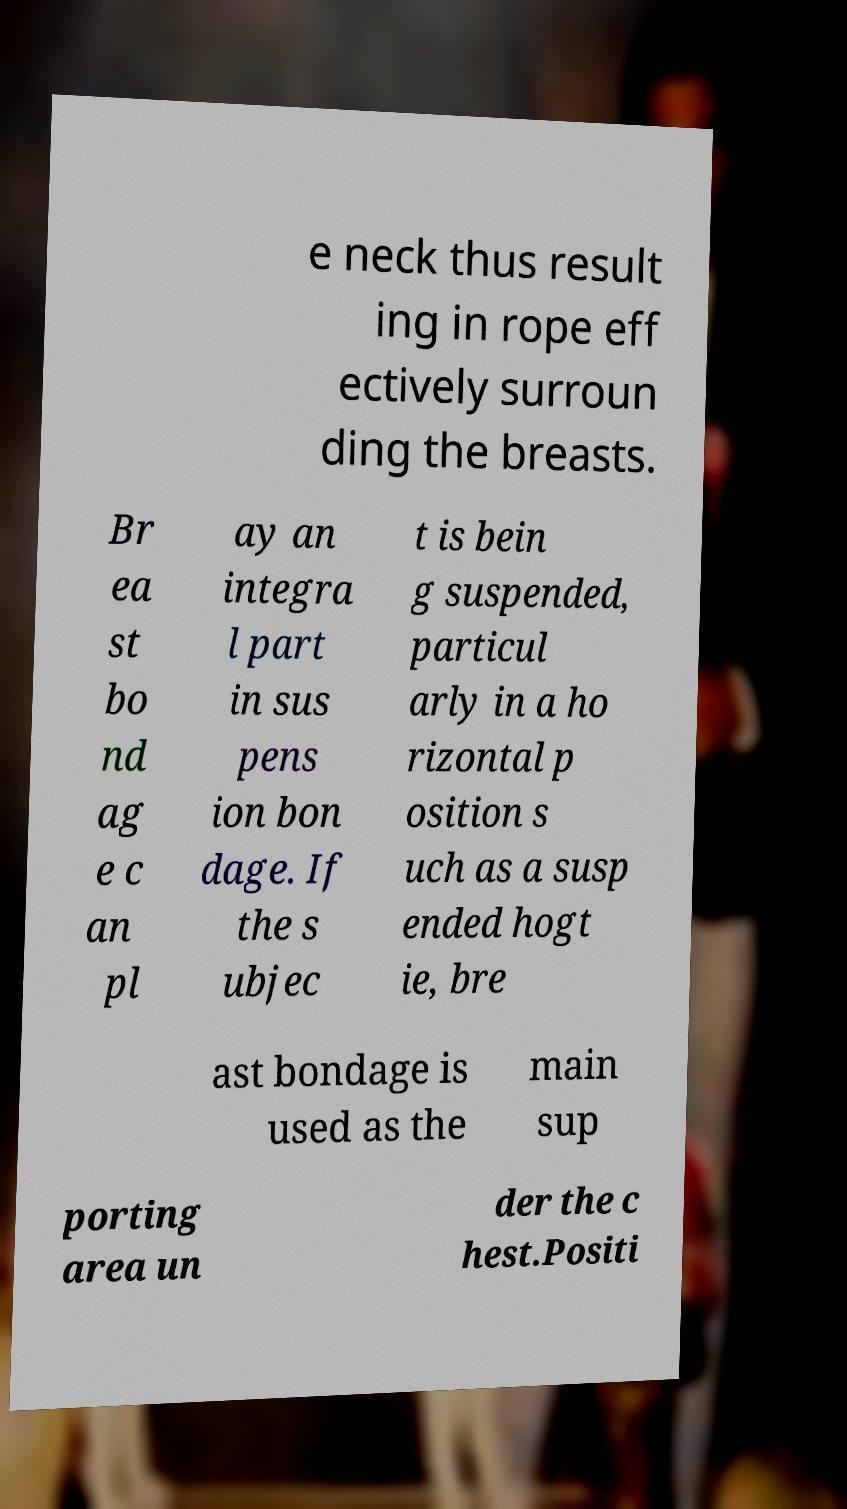For documentation purposes, I need the text within this image transcribed. Could you provide that? e neck thus result ing in rope eff ectively surroun ding the breasts. Br ea st bo nd ag e c an pl ay an integra l part in sus pens ion bon dage. If the s ubjec t is bein g suspended, particul arly in a ho rizontal p osition s uch as a susp ended hogt ie, bre ast bondage is used as the main sup porting area un der the c hest.Positi 